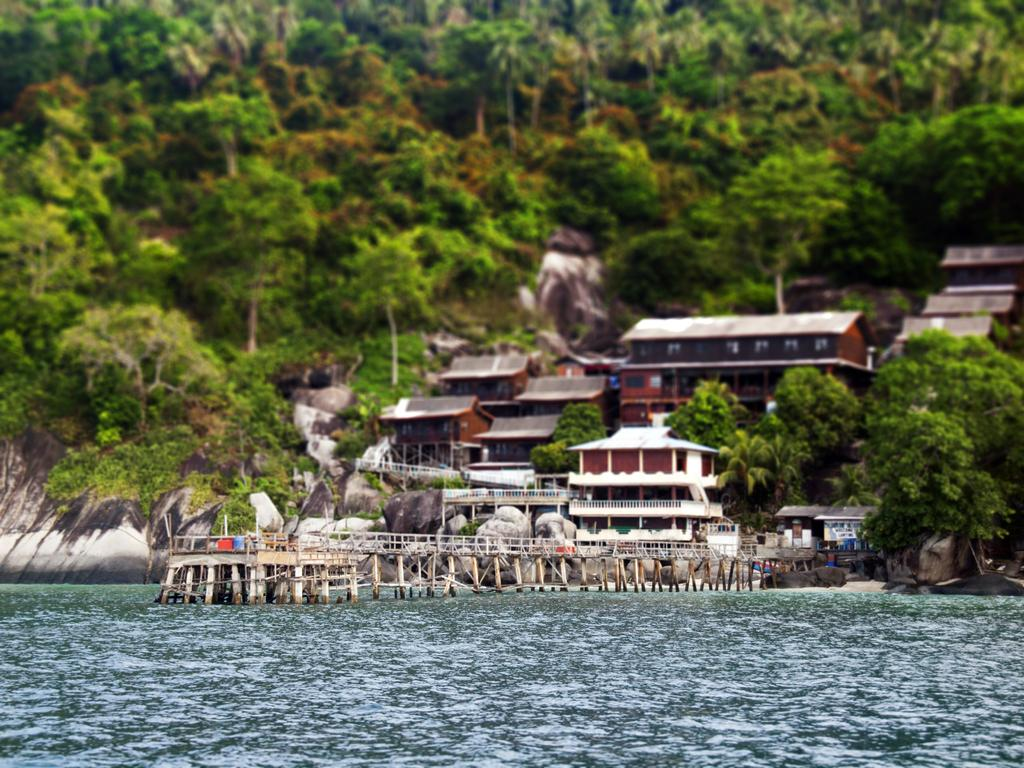What is the main feature of the image? The main feature of the image is water. What structure can be seen crossing over the water? There is a bridge in the image. What other natural elements are present in the image? There are rocks in the image. What type of man-made structures can be seen in the image? There are buildings with windows in the image. What can be seen in the background of the image? There are trees visible in the background of the image. How far away is the ant from the bridge in the image? There is no ant present in the image, so it is not possible to determine the distance between an ant and the bridge. 